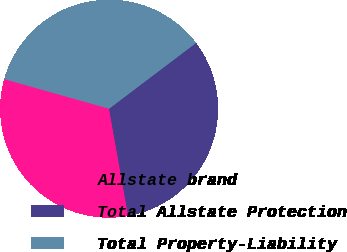Convert chart. <chart><loc_0><loc_0><loc_500><loc_500><pie_chart><fcel>Allstate brand<fcel>Total Allstate Protection<fcel>Total Property-Liability<nl><fcel>32.19%<fcel>32.5%<fcel>35.31%<nl></chart> 